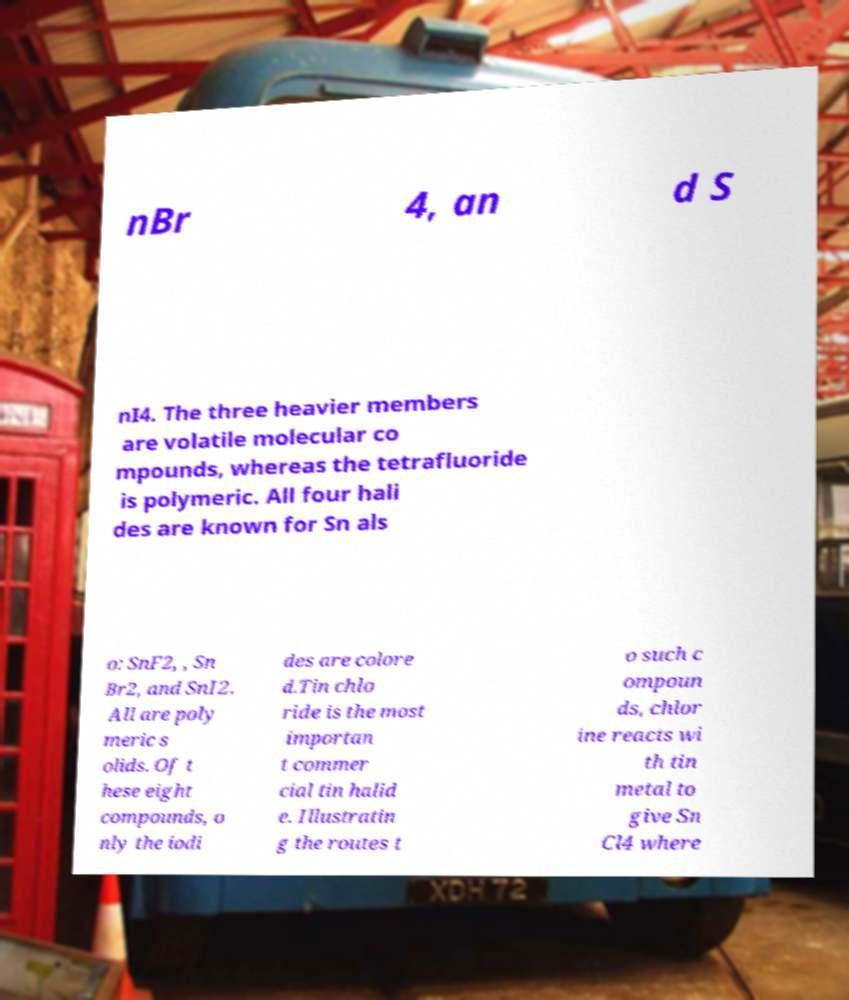There's text embedded in this image that I need extracted. Can you transcribe it verbatim? nBr 4, an d S nI4. The three heavier members are volatile molecular co mpounds, whereas the tetrafluoride is polymeric. All four hali des are known for Sn als o: SnF2, , Sn Br2, and SnI2. All are poly meric s olids. Of t hese eight compounds, o nly the iodi des are colore d.Tin chlo ride is the most importan t commer cial tin halid e. Illustratin g the routes t o such c ompoun ds, chlor ine reacts wi th tin metal to give Sn Cl4 where 